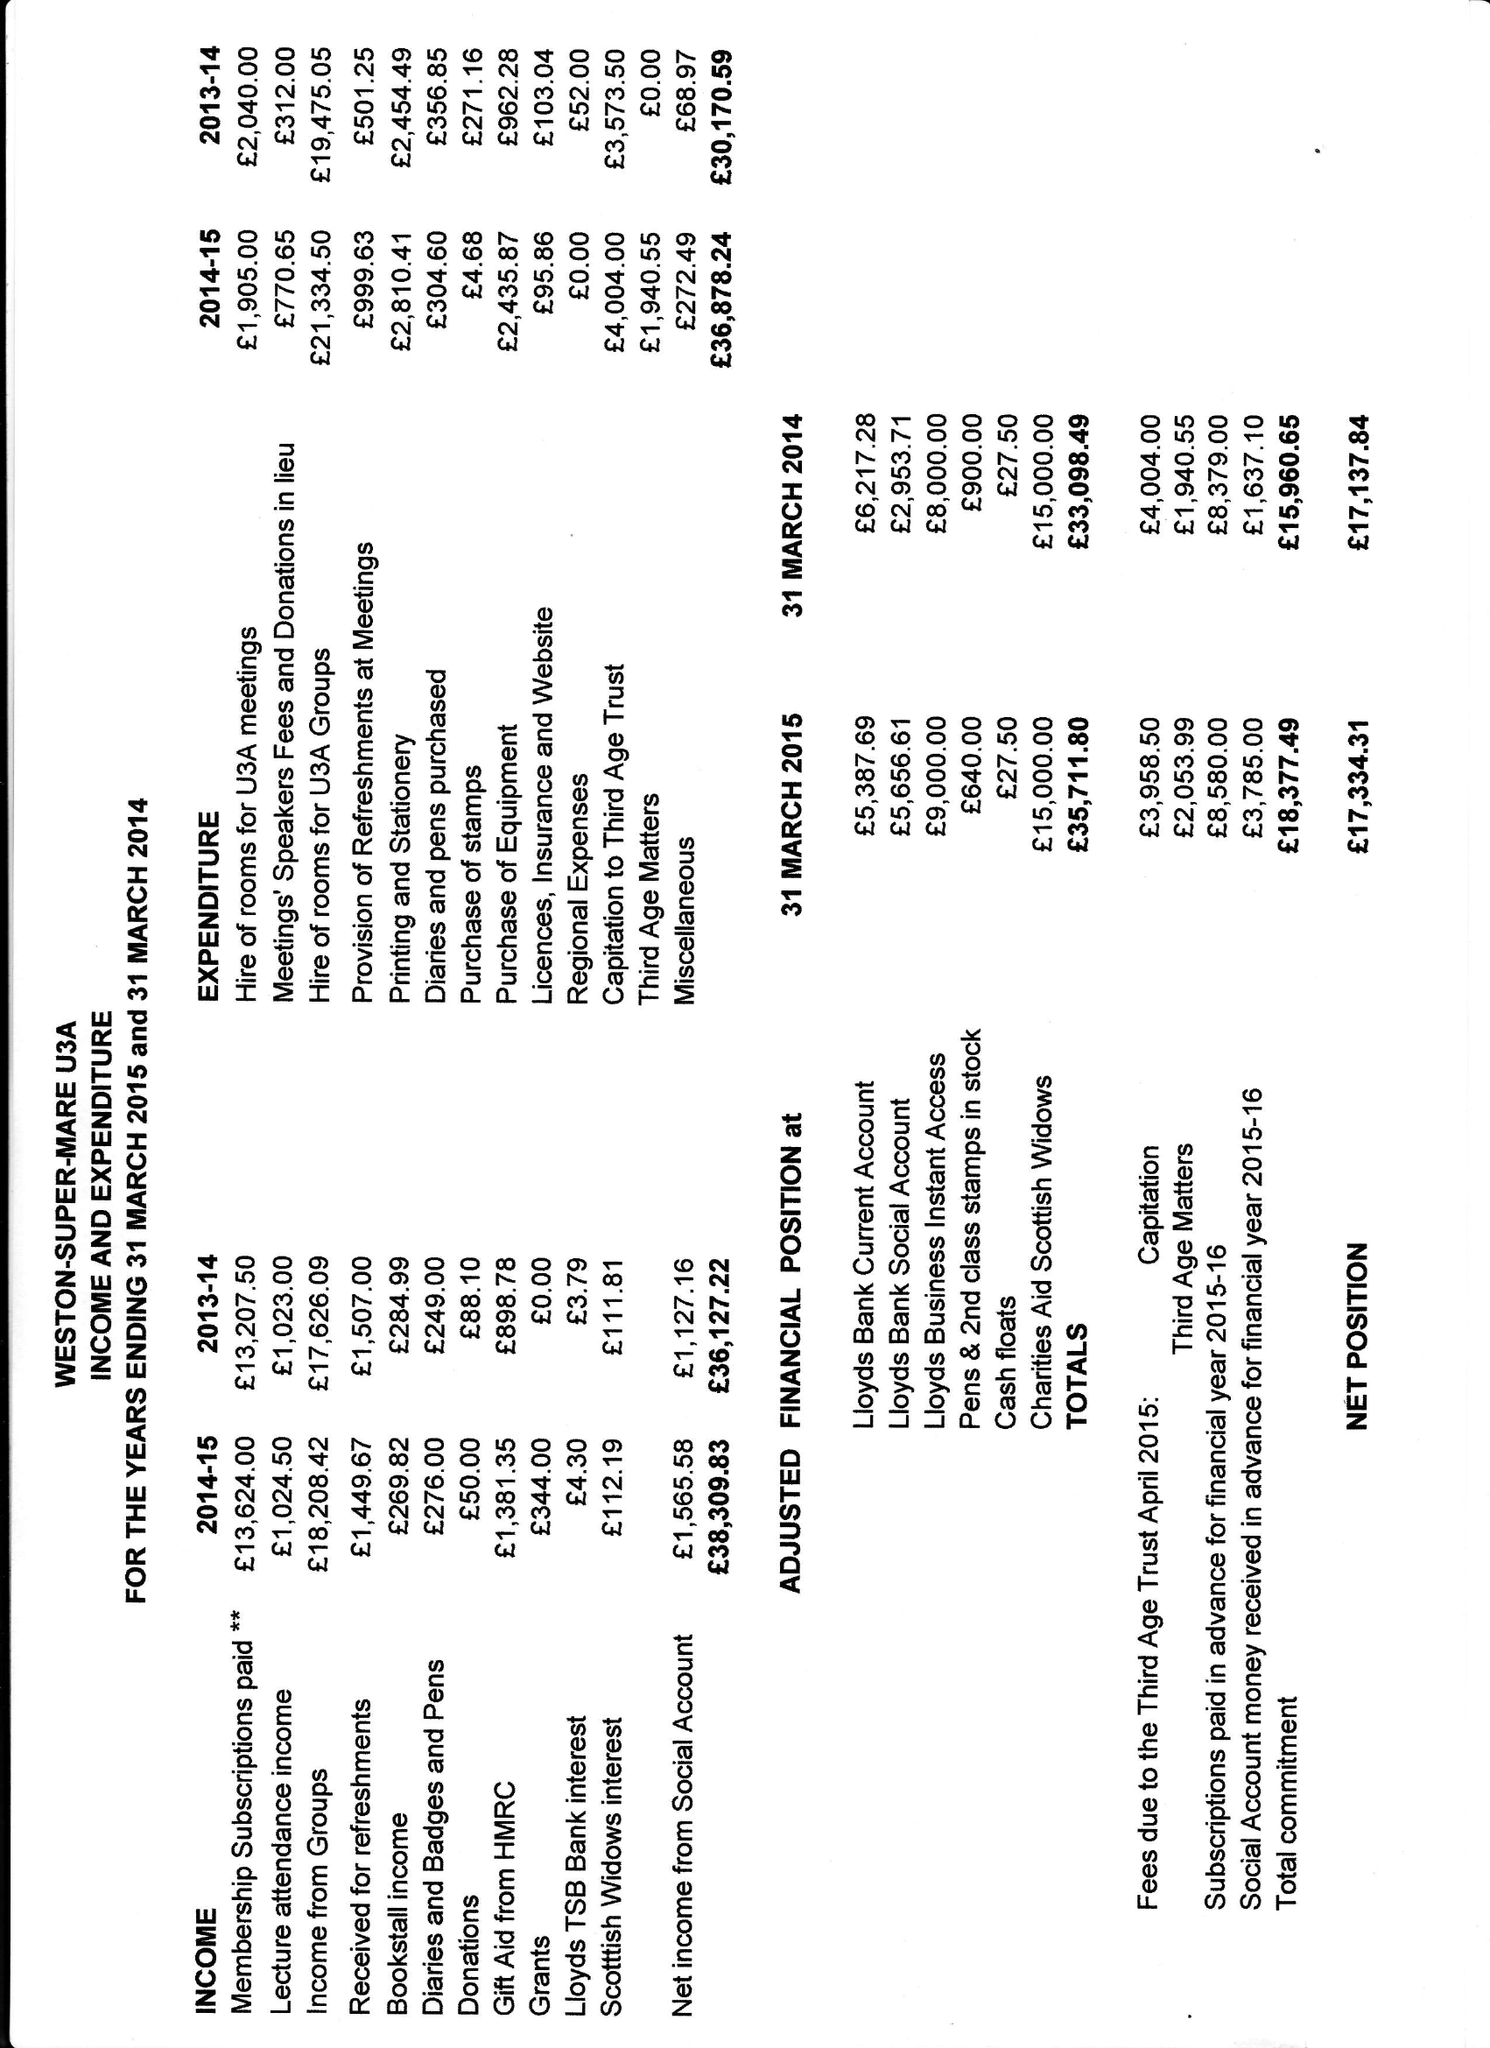What is the value for the report_date?
Answer the question using a single word or phrase. 2015-03-31 